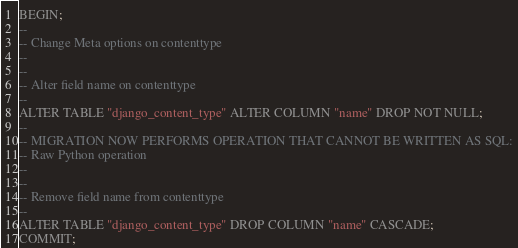Convert code to text. <code><loc_0><loc_0><loc_500><loc_500><_SQL_>BEGIN;
--
-- Change Meta options on contenttype
--
--
-- Alter field name on contenttype
--
ALTER TABLE "django_content_type" ALTER COLUMN "name" DROP NOT NULL;
--
-- MIGRATION NOW PERFORMS OPERATION THAT CANNOT BE WRITTEN AS SQL:
-- Raw Python operation
--
--
-- Remove field name from contenttype
--
ALTER TABLE "django_content_type" DROP COLUMN "name" CASCADE;
COMMIT;
</code> 